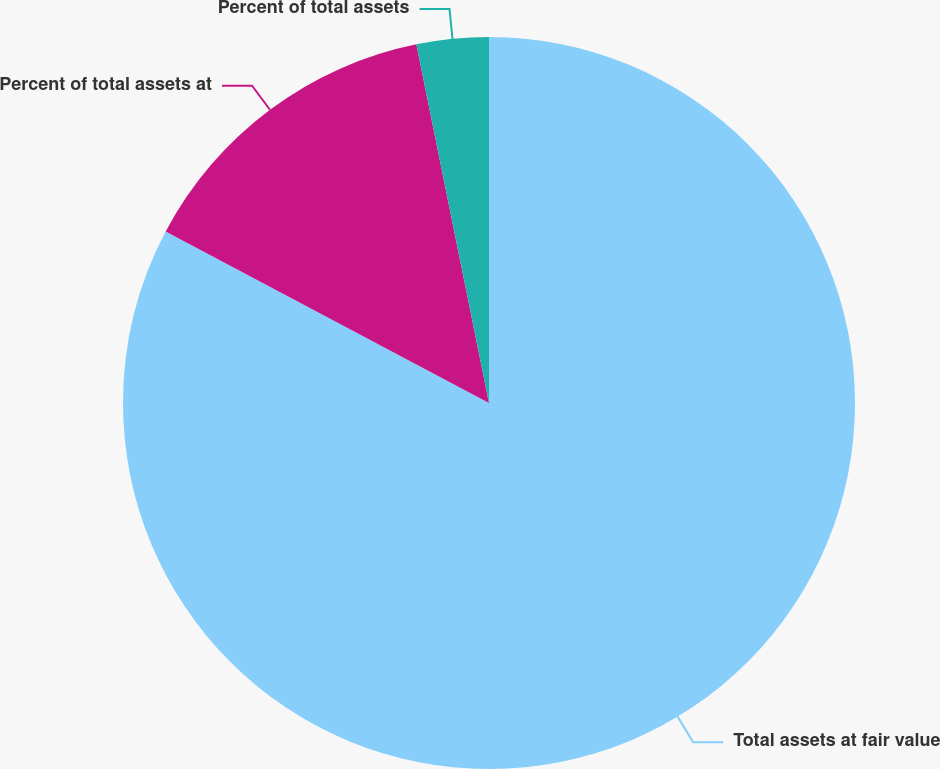Convert chart. <chart><loc_0><loc_0><loc_500><loc_500><pie_chart><fcel>Total assets at fair value<fcel>Percent of total assets at<fcel>Percent of total assets<nl><fcel>82.76%<fcel>14.06%<fcel>3.18%<nl></chart> 